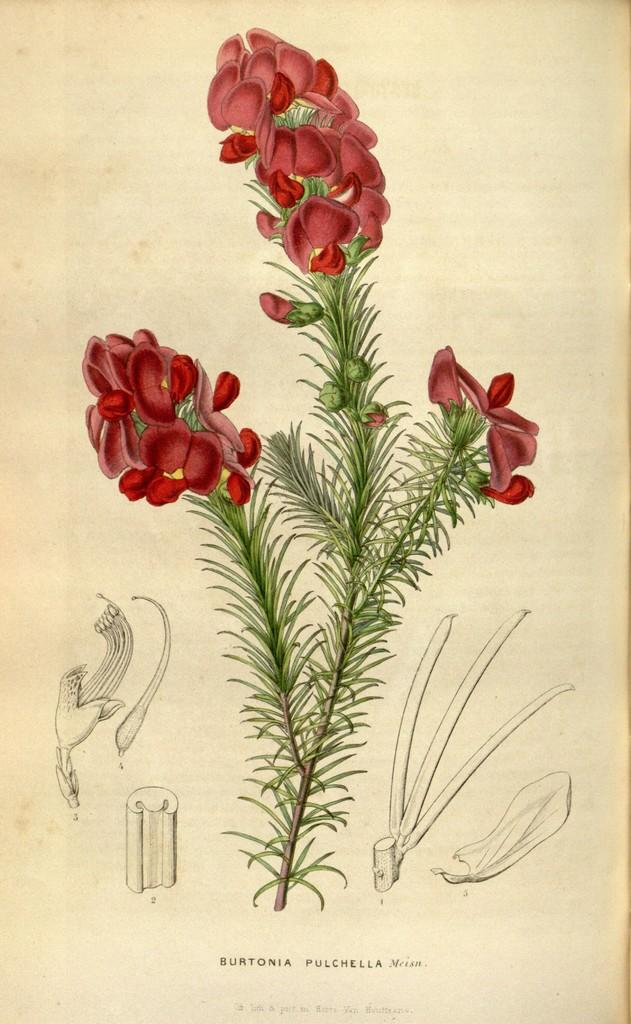What is the main subject of the image? The main subject of the image is a painting of a plant. What day of the week is depicted in the painting of the plant? The painting of the plant does not depict a day of the week; it is a painting of a plant. What type of argument can be seen taking place between the plant and the artist in the painting? There is no argument depicted in the painting of the plant; it is a painting of a plant. 